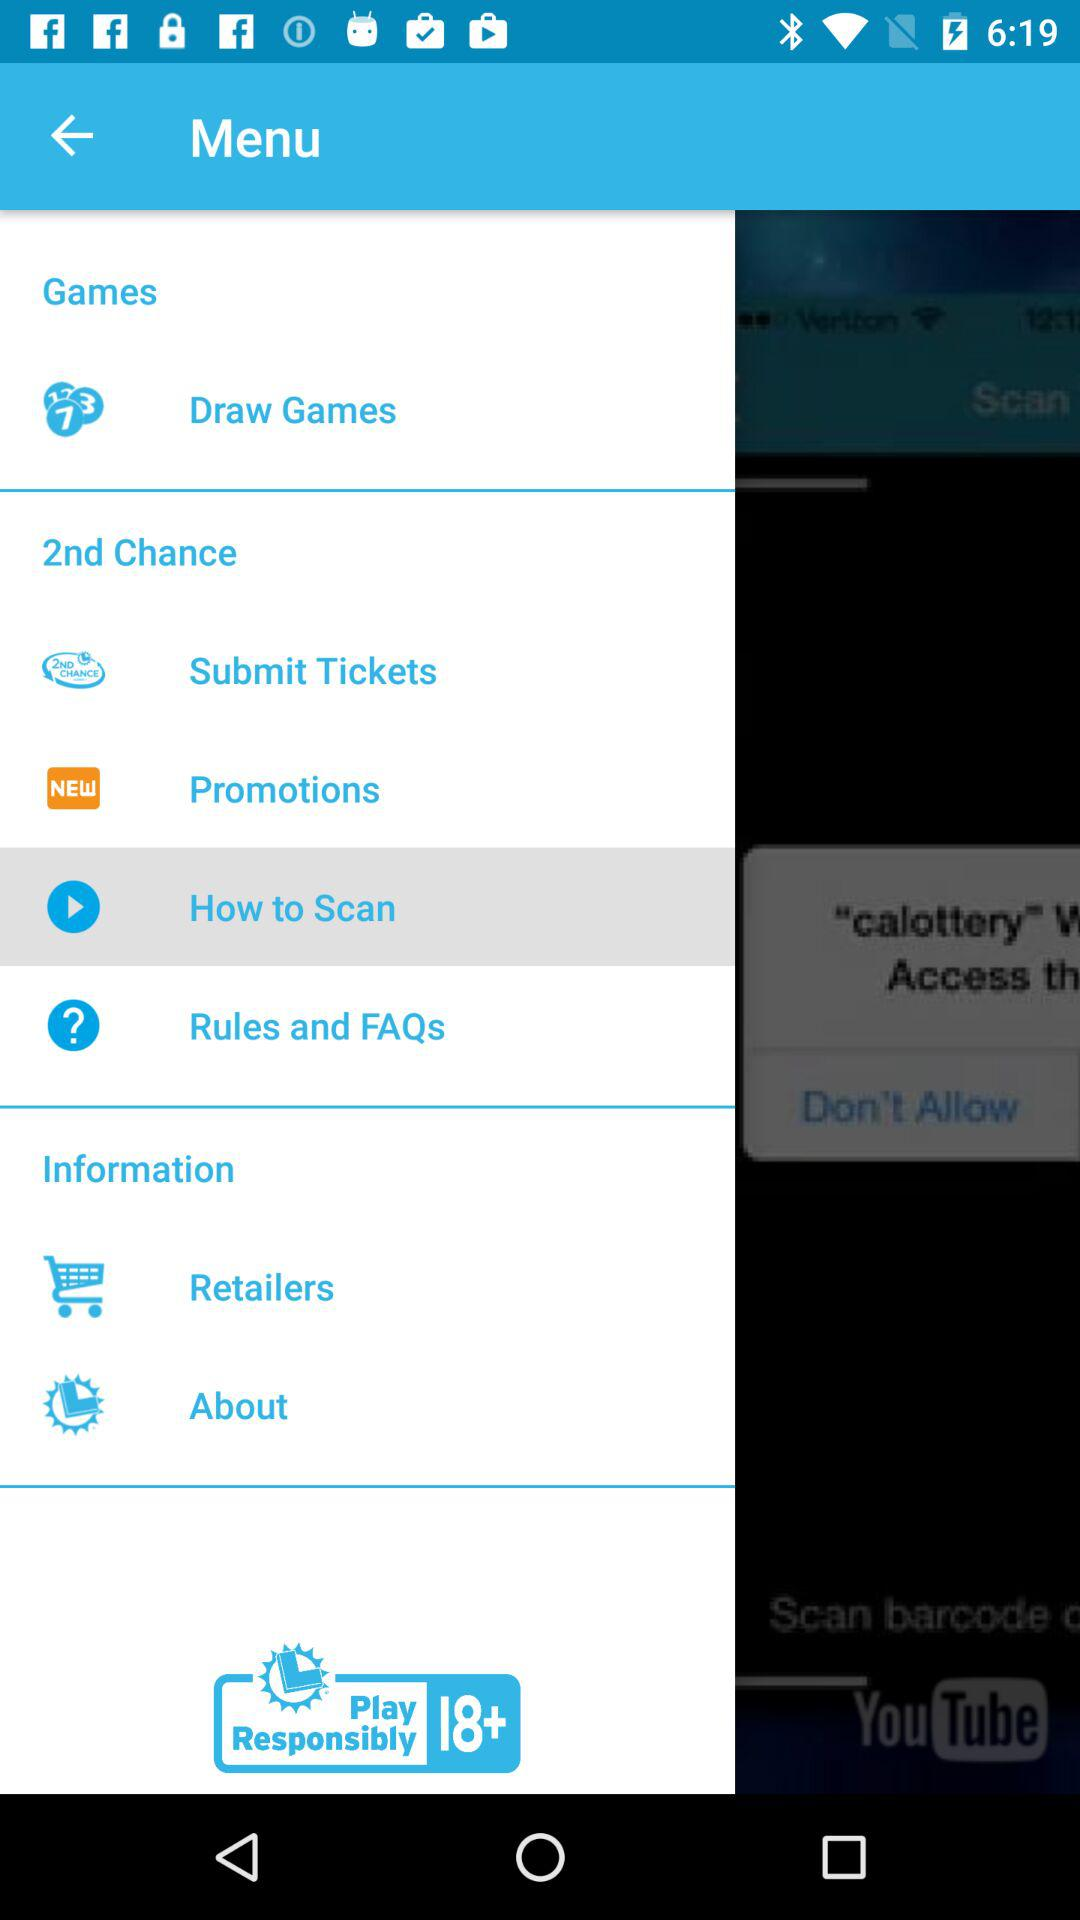What option is selected? The selected option is "How to Scan". 